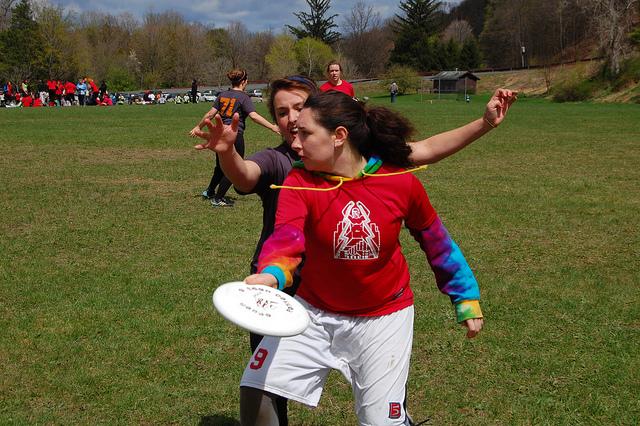Is the sky covered with clouds?
Concise answer only. Yes. What color is the girl with the frisbee's shirt?
Answer briefly. Red. What is she holding?
Be succinct. Frisbee. How many articles of clothing is the woman holding the white frisby earring?
Short answer required. 2. 